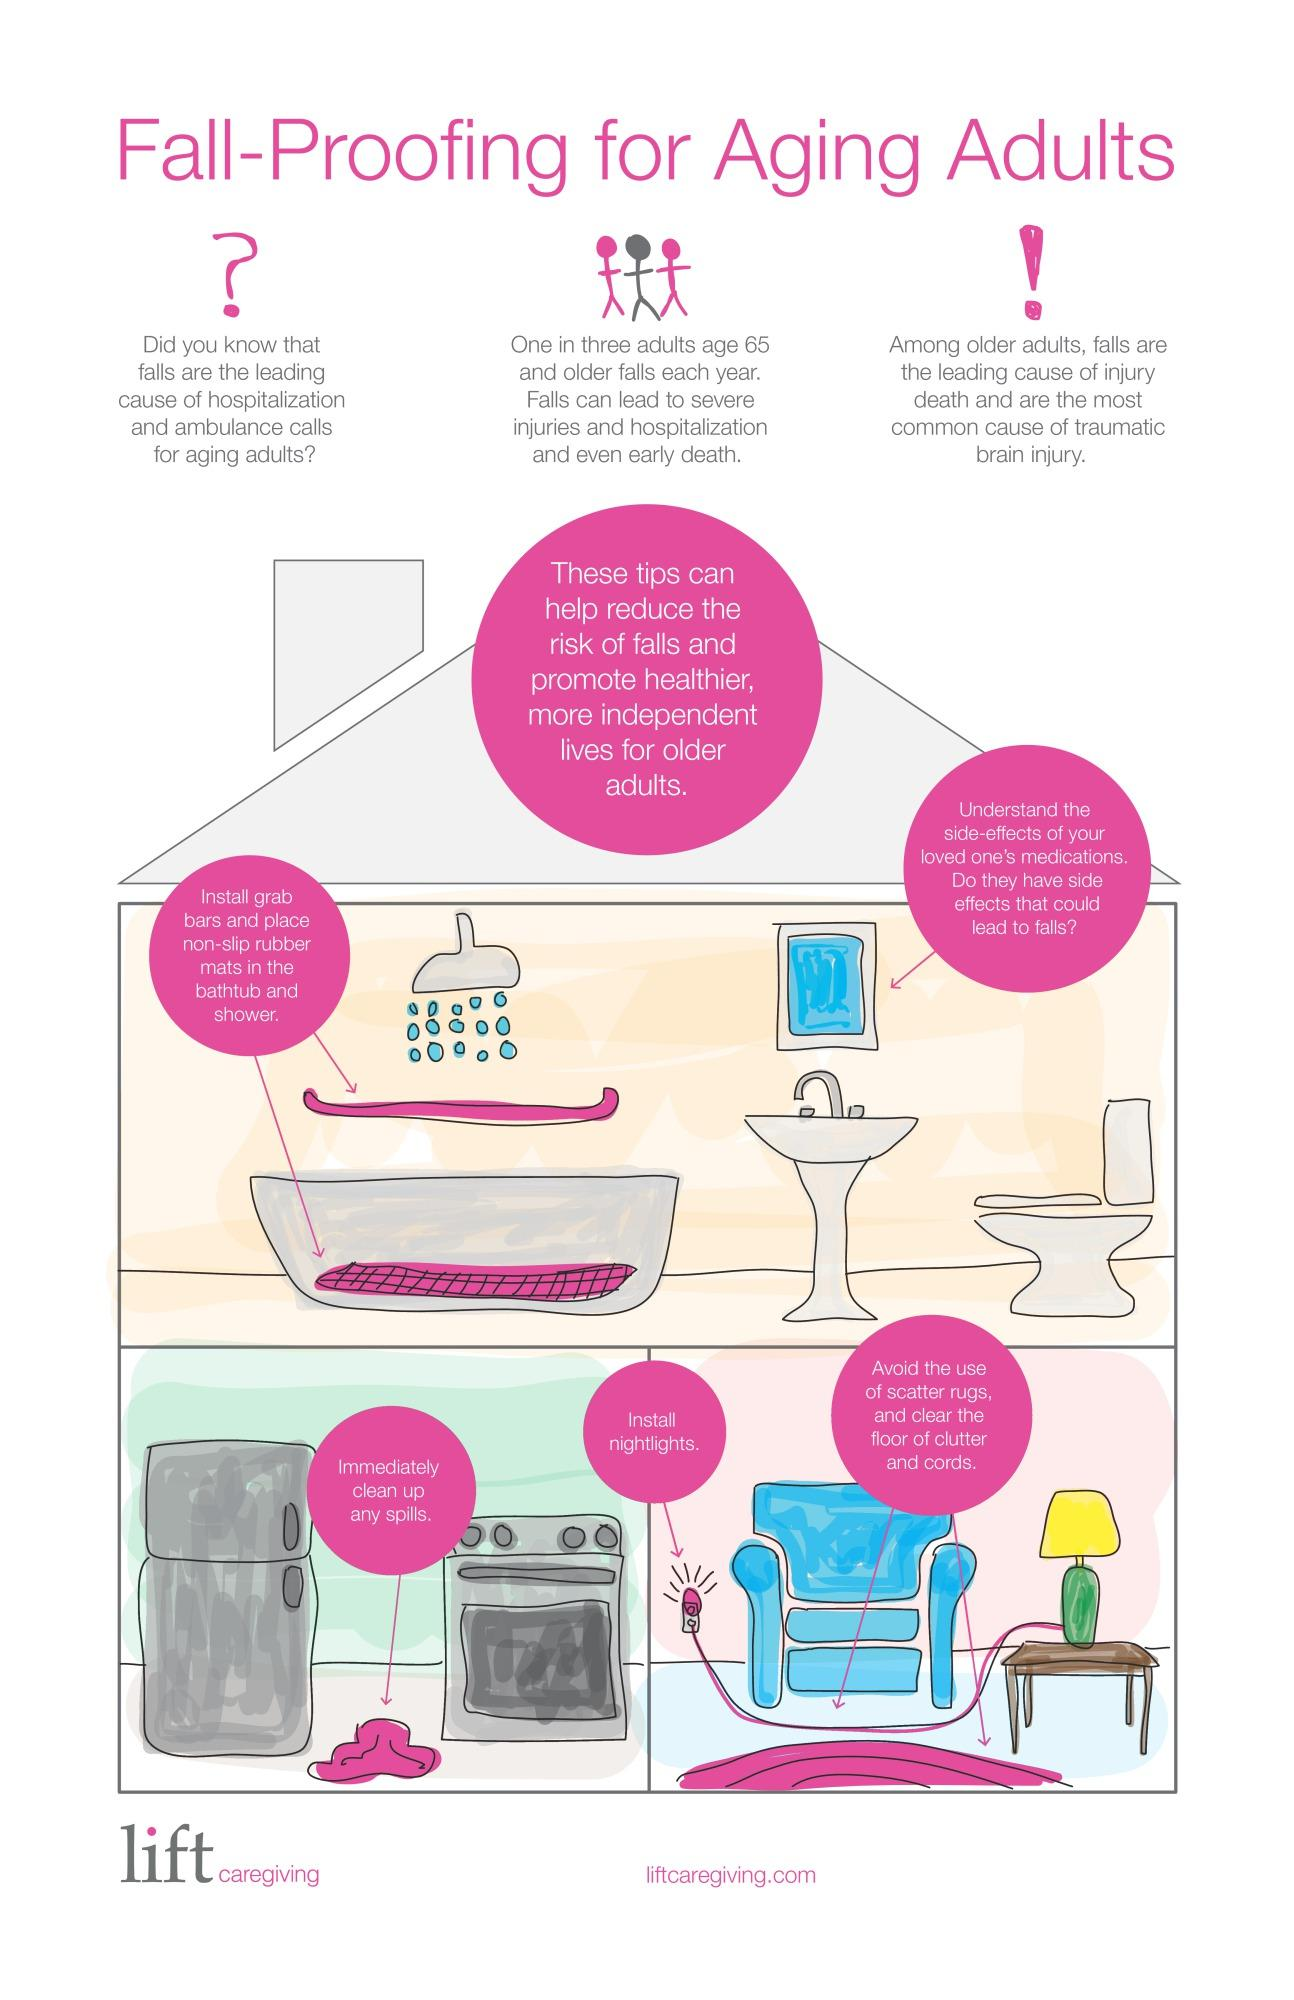Highlight a few significant elements in this photo. Falls are a common occurrence among individuals in the categories of infants, senior citizens, and middle-aged individuals, with senior citizens being the most susceptible to falls. Five tips are mentioned to reduce the risk of falls. The harmful effects of falls, including severe injuries, hospitalization, and even early death, are well-known. 